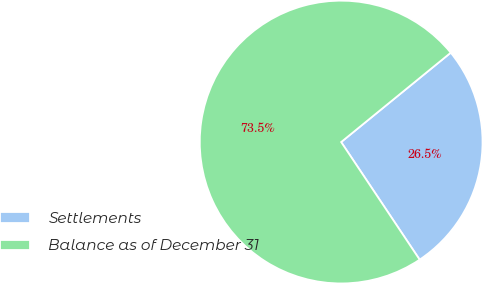<chart> <loc_0><loc_0><loc_500><loc_500><pie_chart><fcel>Settlements<fcel>Balance as of December 31<nl><fcel>26.52%<fcel>73.48%<nl></chart> 